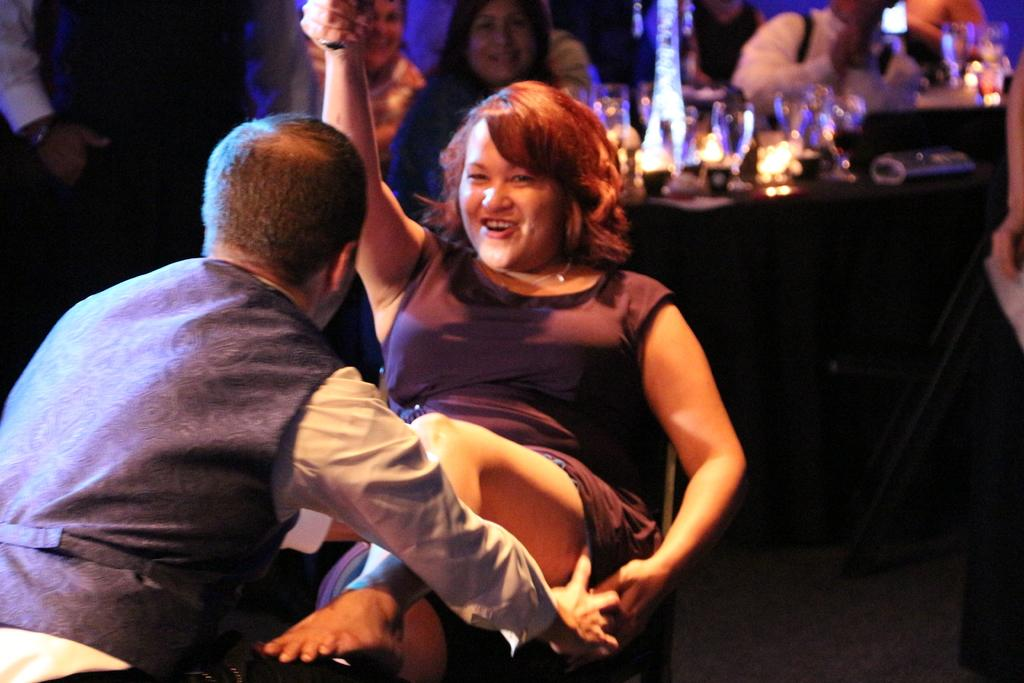Who or what is present in the image? There are people in the image. What objects can be seen with the people? There are glasses in the image. How would you describe the quality of the image's background? The image is blurry in the background. What type of whip is being used by the people in the image? There is no whip present in the image. What country is depicted in the background of the image? The image does not depict any specific country; it is blurry in the background. 